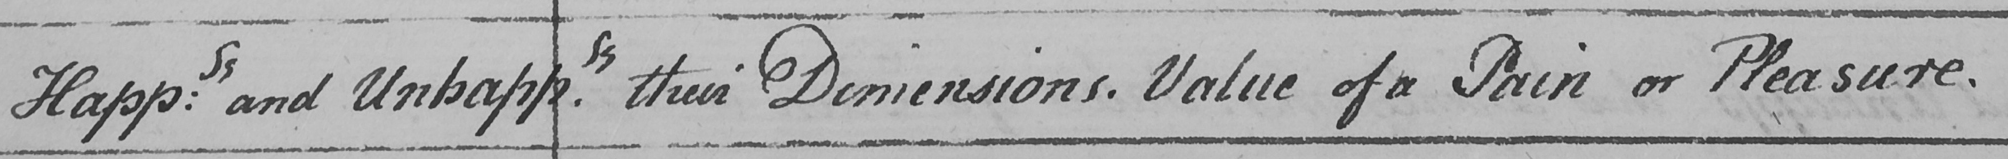Please transcribe the handwritten text in this image. Happ : ss and Unhapp.ss their Dimensions . Value of a Pain or Pleasure . 